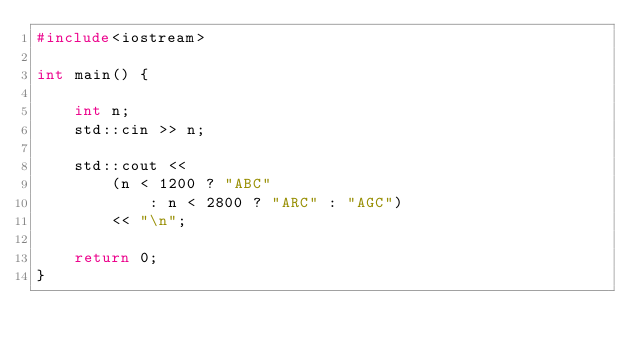<code> <loc_0><loc_0><loc_500><loc_500><_C++_>#include<iostream>

int main() {

	int n;
	std::cin >> n;

	std::cout <<
		(n < 1200 ? "ABC"
			: n < 2800 ? "ARC" : "AGC")
		<< "\n";

	return 0;
}</code> 